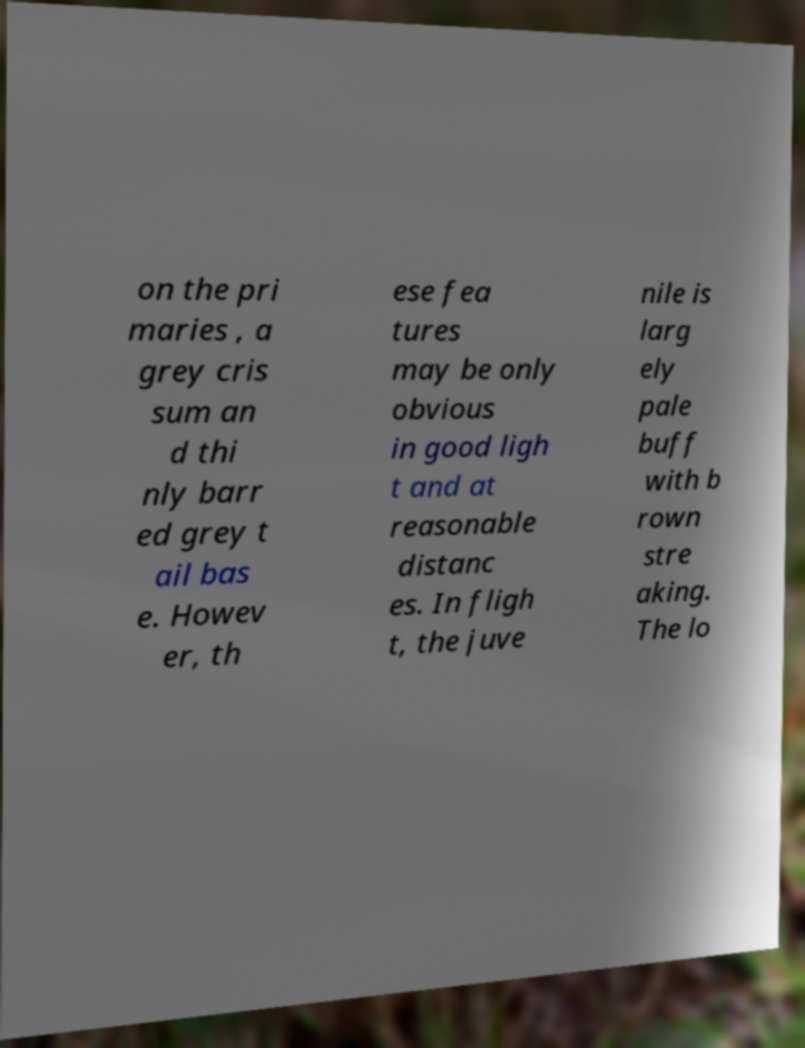I need the written content from this picture converted into text. Can you do that? on the pri maries , a grey cris sum an d thi nly barr ed grey t ail bas e. Howev er, th ese fea tures may be only obvious in good ligh t and at reasonable distanc es. In fligh t, the juve nile is larg ely pale buff with b rown stre aking. The lo 